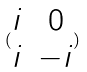<formula> <loc_0><loc_0><loc_500><loc_500>( \begin{matrix} i & 0 \\ i & - i \end{matrix} )</formula> 